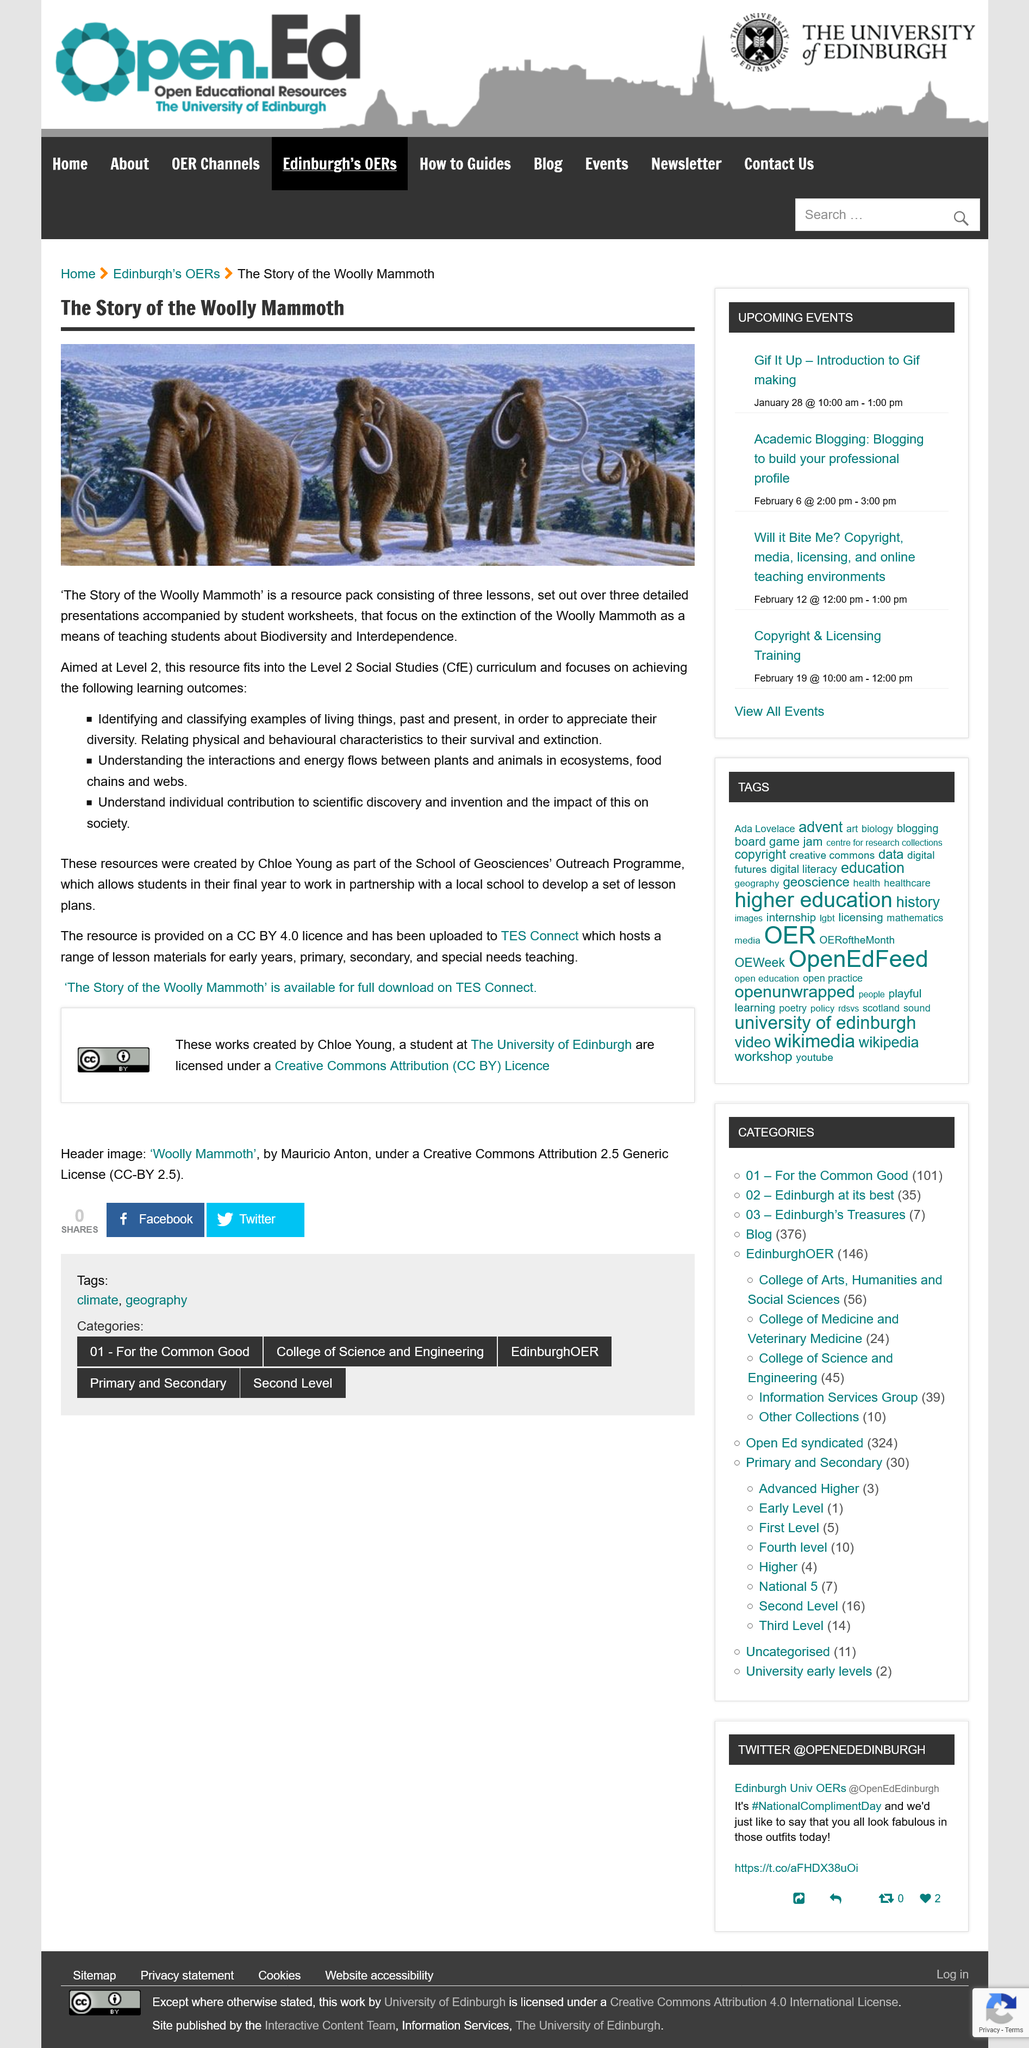Identify some key points in this picture. I, [user's name], declare that the "The Story of the Woolly Mammoth" resource pack consists of three lessons. The Level 2 Social Studies (CfE) curriculum includes focusing on understanding the energy flows between plants and animals. The resource pack "The Story of the Woolly Mammoth" was created by Chloe Young. 